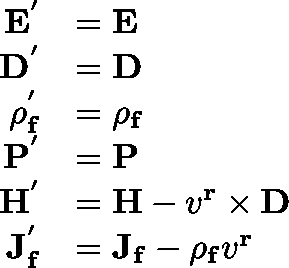Convert formula to latex. <formula><loc_0><loc_0><loc_500><loc_500>{ \begin{array} { r l } { E ^ { ^ { \prime } } } & { = E } \\ { D ^ { ^ { \prime } } } & { = D } \\ { \rho _ { f } ^ { ^ { \prime } } } & { = \rho _ { f } } \\ { P ^ { ^ { \prime } } } & { = P } \\ { H ^ { ^ { \prime } } } & { = H - v ^ { r } \times D } \\ { J _ { f } ^ { ^ { \prime } } } & { = J _ { f } - \rho _ { f } v ^ { r } } \end{array} }</formula> 